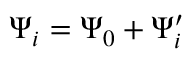Convert formula to latex. <formula><loc_0><loc_0><loc_500><loc_500>\Psi _ { i } = \Psi _ { 0 } + \Psi _ { i } ^ { \prime }</formula> 